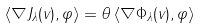Convert formula to latex. <formula><loc_0><loc_0><loc_500><loc_500>\left \langle \nabla J _ { \lambda } ( v ) , \varphi \right \rangle = \theta \left \langle \nabla \Phi _ { \lambda } ( v ) , \varphi \right \rangle</formula> 